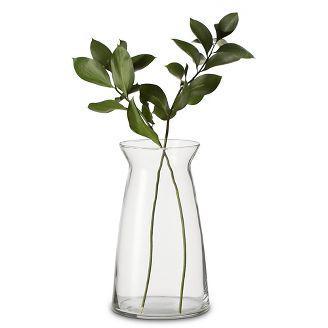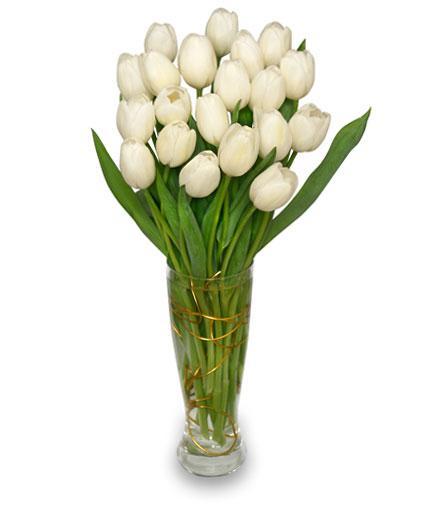The first image is the image on the left, the second image is the image on the right. Evaluate the accuracy of this statement regarding the images: "An image shows a vase containing at least one white tulip.". Is it true? Answer yes or no. Yes. 